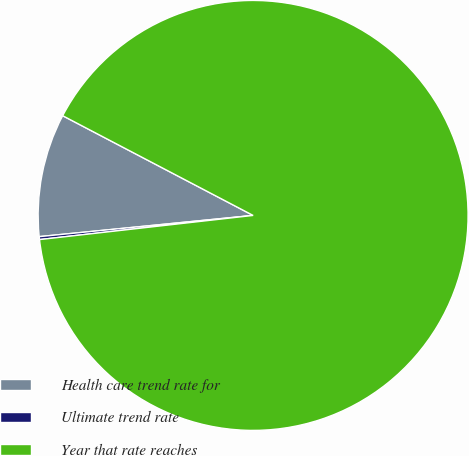<chart> <loc_0><loc_0><loc_500><loc_500><pie_chart><fcel>Health care trend rate for<fcel>Ultimate trend rate<fcel>Year that rate reaches<nl><fcel>9.25%<fcel>0.22%<fcel>90.52%<nl></chart> 